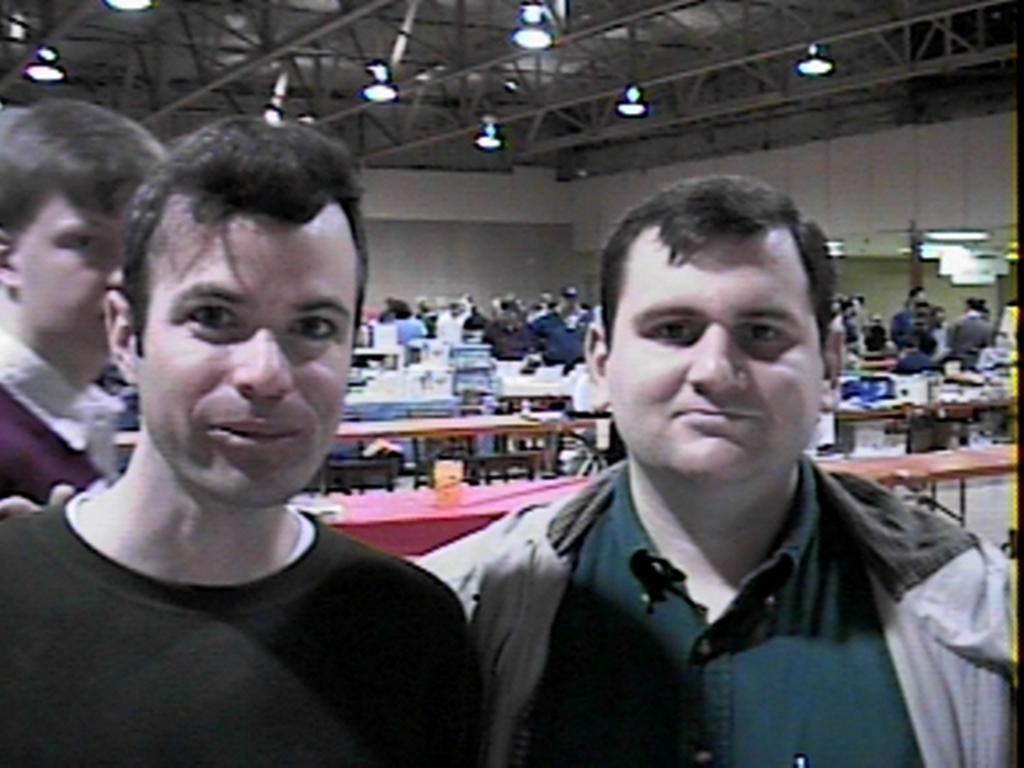Can you describe this image briefly? In this image we can see some people. On the backside we can see some benches and a group of people standing. We can also see a wall and a roof with some ceiling lights. 